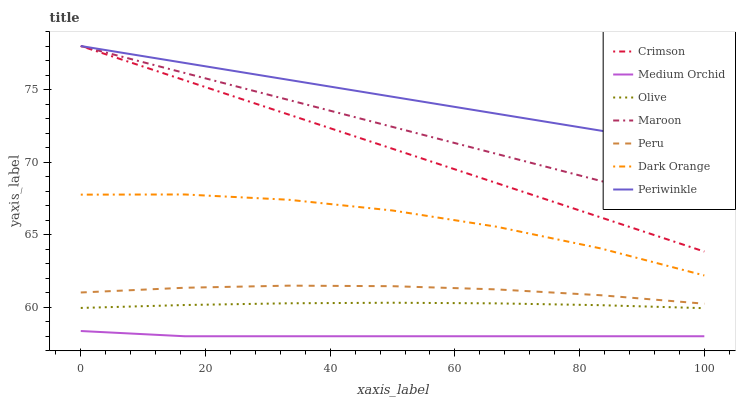Does Medium Orchid have the minimum area under the curve?
Answer yes or no. Yes. Does Periwinkle have the maximum area under the curve?
Answer yes or no. Yes. Does Maroon have the minimum area under the curve?
Answer yes or no. No. Does Maroon have the maximum area under the curve?
Answer yes or no. No. Is Periwinkle the smoothest?
Answer yes or no. Yes. Is Dark Orange the roughest?
Answer yes or no. Yes. Is Medium Orchid the smoothest?
Answer yes or no. No. Is Medium Orchid the roughest?
Answer yes or no. No. Does Medium Orchid have the lowest value?
Answer yes or no. Yes. Does Maroon have the lowest value?
Answer yes or no. No. Does Crimson have the highest value?
Answer yes or no. Yes. Does Medium Orchid have the highest value?
Answer yes or no. No. Is Medium Orchid less than Dark Orange?
Answer yes or no. Yes. Is Maroon greater than Peru?
Answer yes or no. Yes. Does Maroon intersect Periwinkle?
Answer yes or no. Yes. Is Maroon less than Periwinkle?
Answer yes or no. No. Is Maroon greater than Periwinkle?
Answer yes or no. No. Does Medium Orchid intersect Dark Orange?
Answer yes or no. No. 